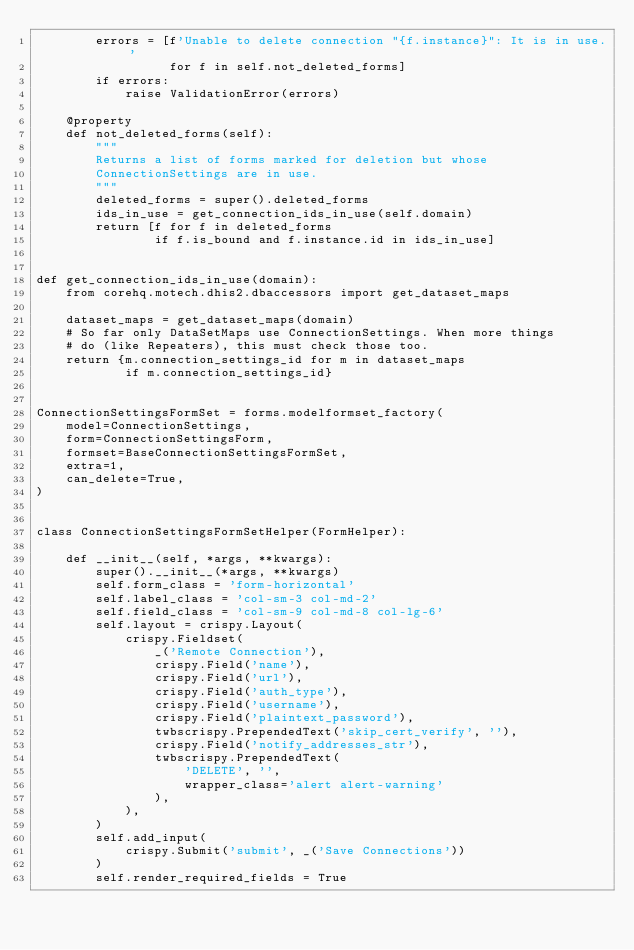<code> <loc_0><loc_0><loc_500><loc_500><_Python_>        errors = [f'Unable to delete connection "{f.instance}": It is in use.'
                  for f in self.not_deleted_forms]
        if errors:
            raise ValidationError(errors)

    @property
    def not_deleted_forms(self):
        """
        Returns a list of forms marked for deletion but whose
        ConnectionSettings are in use.
        """
        deleted_forms = super().deleted_forms
        ids_in_use = get_connection_ids_in_use(self.domain)
        return [f for f in deleted_forms
                if f.is_bound and f.instance.id in ids_in_use]


def get_connection_ids_in_use(domain):
    from corehq.motech.dhis2.dbaccessors import get_dataset_maps

    dataset_maps = get_dataset_maps(domain)
    # So far only DataSetMaps use ConnectionSettings. When more things
    # do (like Repeaters), this must check those too.
    return {m.connection_settings_id for m in dataset_maps
            if m.connection_settings_id}


ConnectionSettingsFormSet = forms.modelformset_factory(
    model=ConnectionSettings,
    form=ConnectionSettingsForm,
    formset=BaseConnectionSettingsFormSet,
    extra=1,
    can_delete=True,
)


class ConnectionSettingsFormSetHelper(FormHelper):

    def __init__(self, *args, **kwargs):
        super().__init__(*args, **kwargs)
        self.form_class = 'form-horizontal'
        self.label_class = 'col-sm-3 col-md-2'
        self.field_class = 'col-sm-9 col-md-8 col-lg-6'
        self.layout = crispy.Layout(
            crispy.Fieldset(
                _('Remote Connection'),
                crispy.Field('name'),
                crispy.Field('url'),
                crispy.Field('auth_type'),
                crispy.Field('username'),
                crispy.Field('plaintext_password'),
                twbscrispy.PrependedText('skip_cert_verify', ''),
                crispy.Field('notify_addresses_str'),
                twbscrispy.PrependedText(
                    'DELETE', '',
                    wrapper_class='alert alert-warning'
                ),
            ),
        )
        self.add_input(
            crispy.Submit('submit', _('Save Connections'))
        )
        self.render_required_fields = True
</code> 